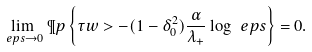<formula> <loc_0><loc_0><loc_500><loc_500>\lim _ { \ e p s \to 0 } \P p \left \{ \tau w > - ( 1 - \delta _ { 0 } ^ { 2 } ) \frac { \alpha } { \lambda _ { + } } \log \ e p s \right \} = 0 .</formula> 